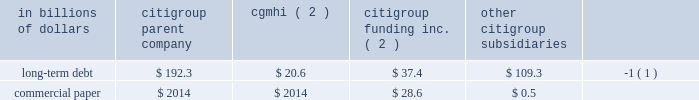Sources of liquidity primary sources of liquidity for citigroup and its principal subsidiaries include : 2022 deposits ; 2022 collateralized financing transactions ; 2022 senior and subordinated debt ; 2022 commercial paper ; 2022 trust preferred and preferred securities ; and 2022 purchased/wholesale funds .
Citigroup 2019s funding sources are diversified across funding types and geography , a benefit of its global franchise .
Funding for citigroup and its major operating subsidiaries includes a geographically diverse retail and corporate deposit base of $ 774.2 billion .
These deposits are diversified across products and regions , with approximately two-thirds of them outside of the u.s .
This diversification provides the company with an important , stable and low-cost source of funding .
A significant portion of these deposits has been , and is expected to be , long-term and stable , and are considered to be core .
There are qualitative as well as quantitative assessments that determine the company 2019s calculation of core deposits .
The first step in this process is a qualitative assessment of the deposits .
For example , as a result of the company 2019s qualitative analysis certain deposits with wholesale funding characteristics are excluded from consideration as core .
Deposits that qualify under the company 2019s qualitative assessments are then subjected to quantitative analysis .
Excluding the impact of changes in foreign exchange rates and the sale of our retail banking operations in germany during the year ending december 31 , 2008 , the company 2019s deposit base remained stable .
On a volume basis , deposit increases were noted in transaction services , u.s .
Retail banking and smith barney .
This was partially offset by the company 2019s decision to reduce deposits considered wholesale funding , consistent with the company 2019s de-leveraging efforts , and declines in international consumer banking and the private bank .
Citigroup and its subsidiaries have historically had a significant presence in the global capital markets .
The company 2019s capital markets funding activities have been primarily undertaken by two legal entities : ( i ) citigroup inc. , which issues long-term debt , medium-term notes , trust preferred securities , and preferred and common stock ; and ( ii ) citigroup funding inc .
( cfi ) , a first-tier subsidiary of citigroup , which issues commercial paper , medium-term notes and structured equity-linked and credit-linked notes , all of which are guaranteed by citigroup .
Other significant elements of long- term debt on the consolidated balance sheet include collateralized advances from the federal home loan bank system , long-term debt related to the consolidation of icg 2019s structured investment vehicles , asset-backed outstandings , and certain borrowings of foreign subsidiaries .
Each of citigroup 2019s major operating subsidiaries finances its operations on a basis consistent with its capitalization , regulatory structure and the environment in which it operates .
Particular attention is paid to those businesses that for tax , sovereign risk , or regulatory reasons cannot be freely and readily funded in the international markets .
Citigroup 2019s borrowings have historically been diversified by geography , investor , instrument and currency .
Decisions regarding the ultimate currency and interest rate profile of liquidity generated through these borrowings can be separated from the actual issuance through the use of derivative instruments .
Citigroup is a provider of liquidity facilities to the commercial paper programs of the two primary credit card securitization trusts with which it transacts .
Citigroup may also provide other types of support to the trusts .
As a result of the recent economic downturn , its impact on the cashflows of the trusts , and in response to credit rating agency reviews of the trusts , the company increased the credit enhancement in the omni trust , and plans to provide additional enhancement to the master trust ( see note 23 to consolidated financial statements on page 175 for a further discussion ) .
This support preserves investor sponsorship of our card securitization franchise , an important source of liquidity .
Banking subsidiaries there are various legal limitations on the ability of citigroup 2019s subsidiary depository institutions to extend credit , pay dividends or otherwise supply funds to citigroup and its non-bank subsidiaries .
The approval of the office of the comptroller of the currency , in the case of national banks , or the office of thrift supervision , in the case of federal savings banks , is required if total dividends declared in any calendar year exceed amounts specified by the applicable agency 2019s regulations .
State-chartered depository institutions are subject to dividend limitations imposed by applicable state law .
In determining the declaration of dividends , each depository institution must also consider its effect on applicable risk-based capital and leverage ratio requirements , as well as policy statements of the federal regulatory agencies that indicate that banking organizations should generally pay dividends out of current operating earnings .
Non-banking subsidiaries citigroup also receives dividends from its non-bank subsidiaries .
These non-bank subsidiaries are generally not subject to regulatory restrictions on dividends .
However , as discussed in 201ccapital resources and liquidity 201d on page 94 , the ability of cgmhi to declare dividends can be restricted by capital considerations of its broker-dealer subsidiaries .
Cgmhi 2019s consolidated balance sheet is liquid , with the vast majority of its assets consisting of marketable securities and collateralized short-term financing agreements arising from securities transactions .
Cgmhi monitors and evaluates the adequacy of its capital and borrowing base on a daily basis to maintain liquidity and to ensure that its capital base supports the regulatory capital requirements of its subsidiaries .
Some of citigroup 2019s non-bank subsidiaries , including cgmhi , have credit facilities with citigroup 2019s subsidiary depository institutions , including citibank , n.a .
Borrowings under these facilities must be secured in accordance with section 23a of the federal reserve act .
There are various legal restrictions on the extent to which a bank holding company and certain of its non-bank subsidiaries can borrow or obtain credit from citigroup 2019s subsidiary depository institutions or engage in certain other transactions with them .
In general , these restrictions require that transactions be on arm 2019s length terms and be secured by designated amounts of specified collateral .
See note 20 to the consolidated financial statements on page 169 .
At december 31 , 2008 , long-term debt and commercial paper outstanding for citigroup , cgmhi , cfi and citigroup 2019s subsidiaries were as follows : in billions of dollars citigroup parent company cgmhi ( 2 ) citigroup funding inc .
( 2 ) citigroup subsidiaries long-term debt $ 192.3 $ 20.6 $ 37.4 $ 109.3 ( 1 ) .
( 1 ) at december 31 , 2008 , approximately $ 67.4 billion relates to collateralized advances from the federal home loan bank .
( 2 ) citigroup inc .
Guarantees all of cfi 2019s debt and cgmhi 2019s publicly issued securities. .
What is the total commercial paper in billions of dollars for citigroup , cgmhi , cfi and citigroup 2019s subsidiaries at december 31 , 2008? 
Computations: (28.6 + 0.5)
Answer: 29.1. 